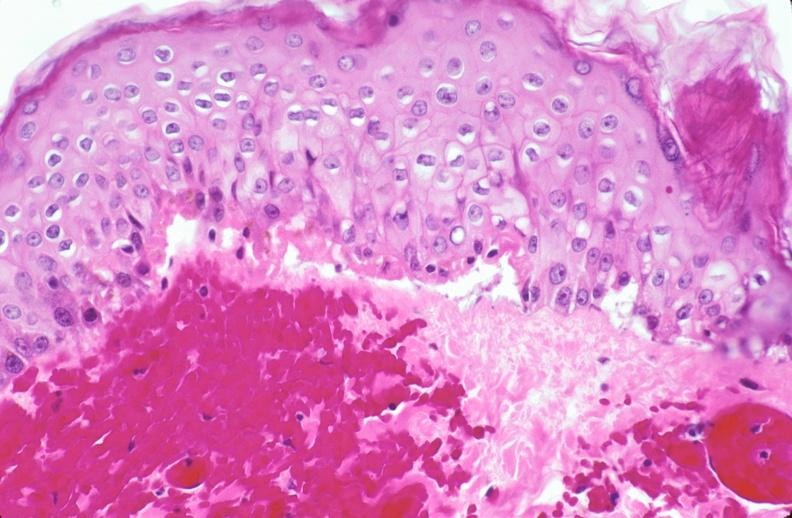what does this image show?
Answer the question using a single word or phrase. Skin 